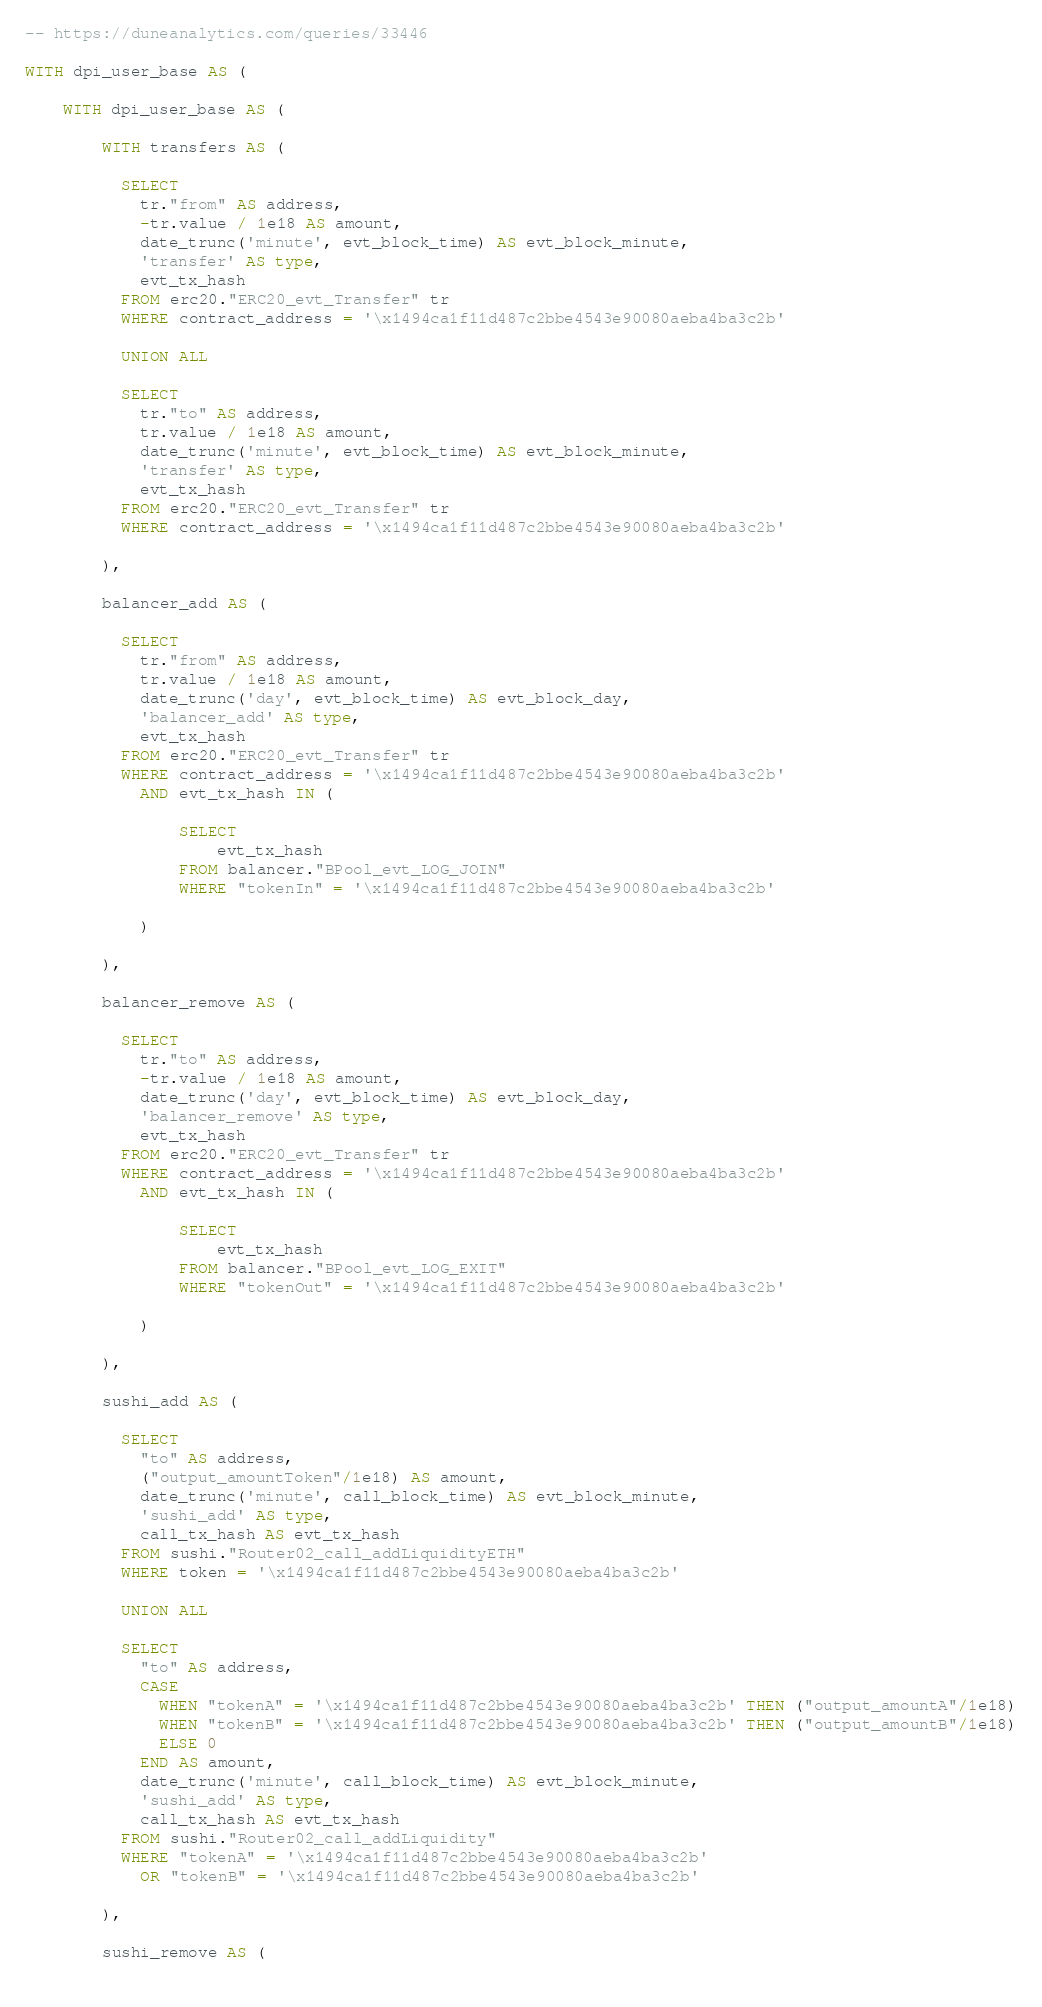Convert code to text. <code><loc_0><loc_0><loc_500><loc_500><_SQL_>-- https://duneanalytics.com/queries/33446

WITH dpi_user_base AS (

    WITH dpi_user_base AS (
    
        WITH transfers AS (
        
          SELECT
            tr."from" AS address,
            -tr.value / 1e18 AS amount,
            date_trunc('minute', evt_block_time) AS evt_block_minute,
            'transfer' AS type,
            evt_tx_hash
          FROM erc20."ERC20_evt_Transfer" tr
          WHERE contract_address = '\x1494ca1f11d487c2bbe4543e90080aeba4ba3c2b'
        
          UNION ALL
        
          SELECT
            tr."to" AS address,
            tr.value / 1e18 AS amount,
            date_trunc('minute', evt_block_time) AS evt_block_minute,
            'transfer' AS type,
            evt_tx_hash
          FROM erc20."ERC20_evt_Transfer" tr
          WHERE contract_address = '\x1494ca1f11d487c2bbe4543e90080aeba4ba3c2b'
        
        ),
        
        balancer_add AS (

          SELECT
            tr."from" AS address,
            tr.value / 1e18 AS amount,
            date_trunc('day', evt_block_time) AS evt_block_day,
            'balancer_add' AS type,
            evt_tx_hash
          FROM erc20."ERC20_evt_Transfer" tr
          WHERE contract_address = '\x1494ca1f11d487c2bbe4543e90080aeba4ba3c2b'
            AND evt_tx_hash IN (
            
                SELECT
                    evt_tx_hash
                FROM balancer."BPool_evt_LOG_JOIN"
                WHERE "tokenIn" = '\x1494ca1f11d487c2bbe4543e90080aeba4ba3c2b'
                
            )

        ),

        balancer_remove AS (

          SELECT
            tr."to" AS address,
            -tr.value / 1e18 AS amount,
            date_trunc('day', evt_block_time) AS evt_block_day,
            'balancer_remove' AS type,
            evt_tx_hash
          FROM erc20."ERC20_evt_Transfer" tr
          WHERE contract_address = '\x1494ca1f11d487c2bbe4543e90080aeba4ba3c2b'
            AND evt_tx_hash IN (
            
                SELECT
                    evt_tx_hash
                FROM balancer."BPool_evt_LOG_EXIT"
                WHERE "tokenOut" = '\x1494ca1f11d487c2bbe4543e90080aeba4ba3c2b'
                
            )
            
        ),
        
        sushi_add AS (
        
          SELECT
            "to" AS address,
            ("output_amountToken"/1e18) AS amount,
            date_trunc('minute', call_block_time) AS evt_block_minute,
            'sushi_add' AS type,
            call_tx_hash AS evt_tx_hash
          FROM sushi."Router02_call_addLiquidityETH"
          WHERE token = '\x1494ca1f11d487c2bbe4543e90080aeba4ba3c2b'
        
          UNION ALL
        
          SELECT
            "to" AS address,
            CASE
              WHEN "tokenA" = '\x1494ca1f11d487c2bbe4543e90080aeba4ba3c2b' THEN ("output_amountA"/1e18)
              WHEN "tokenB" = '\x1494ca1f11d487c2bbe4543e90080aeba4ba3c2b' THEN ("output_amountB"/1e18)
              ELSE 0
            END AS amount,
            date_trunc('minute', call_block_time) AS evt_block_minute,
            'sushi_add' AS type,
            call_tx_hash AS evt_tx_hash
          FROM sushi."Router02_call_addLiquidity"
          WHERE "tokenA" = '\x1494ca1f11d487c2bbe4543e90080aeba4ba3c2b'
            OR "tokenB" = '\x1494ca1f11d487c2bbe4543e90080aeba4ba3c2b'
        
        ),
        
        sushi_remove AS (
        </code> 